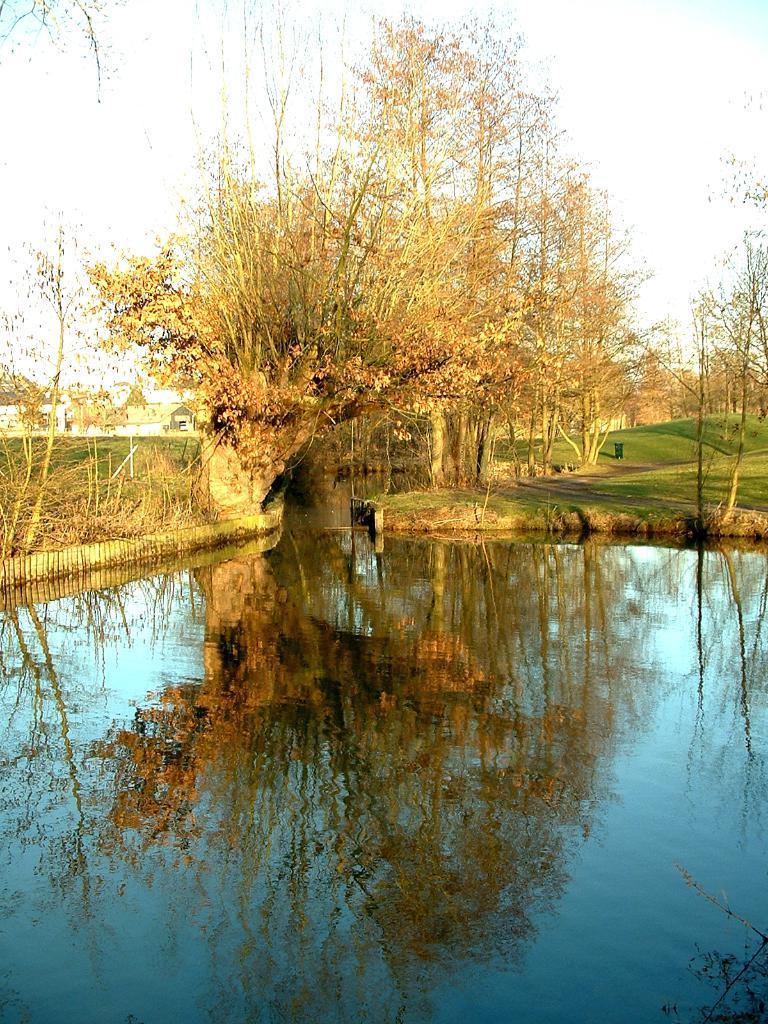Can you describe this image briefly? This image is taken outdoors. At the bottom of the image there is a pond with water. In the middle of the image there is a ground with grass on it and there are many trees and plants on the ground. In the background there are a few houses. 